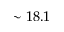Convert formula to latex. <formula><loc_0><loc_0><loc_500><loc_500>\sim 1 8 . 1</formula> 